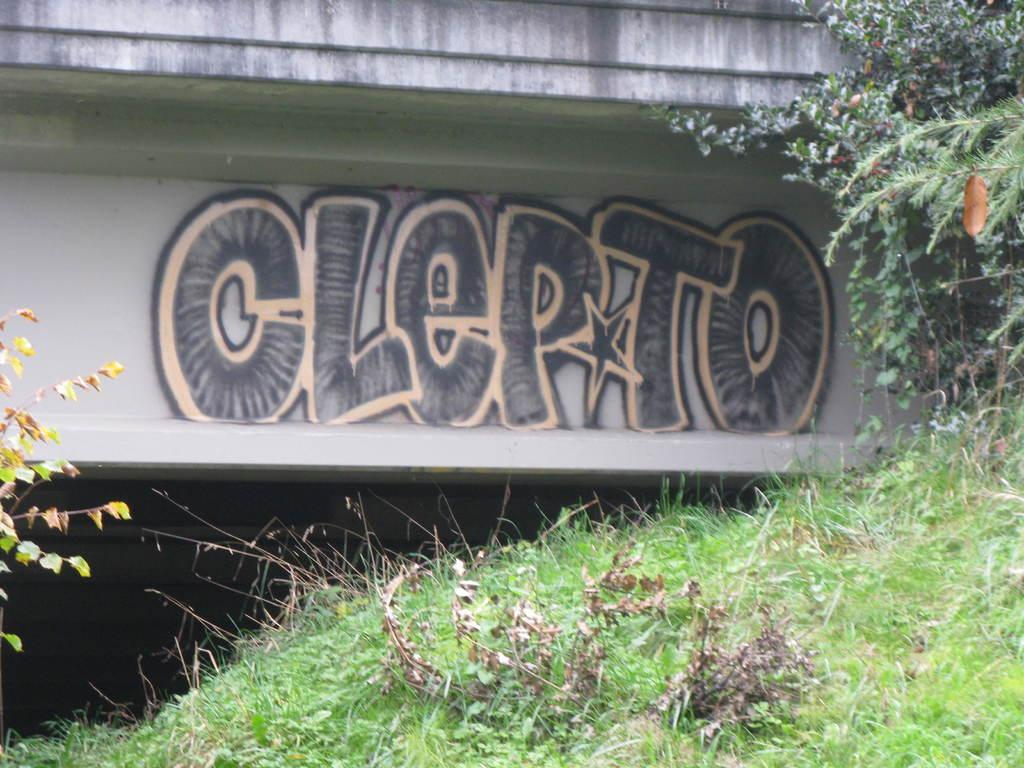What is depicted on the wall in the image? There is a text painting on the wall. What type of surface is on the ground in the image? There is grass on the ground. What other natural elements can be seen in the image? There are trees visible in the image. What type of hook is used to hang the text painting in the image? There is no hook visible in the image, and the method of hanging the text painting is not mentioned. What color is the copper used in the image? There is no copper present in the image. 